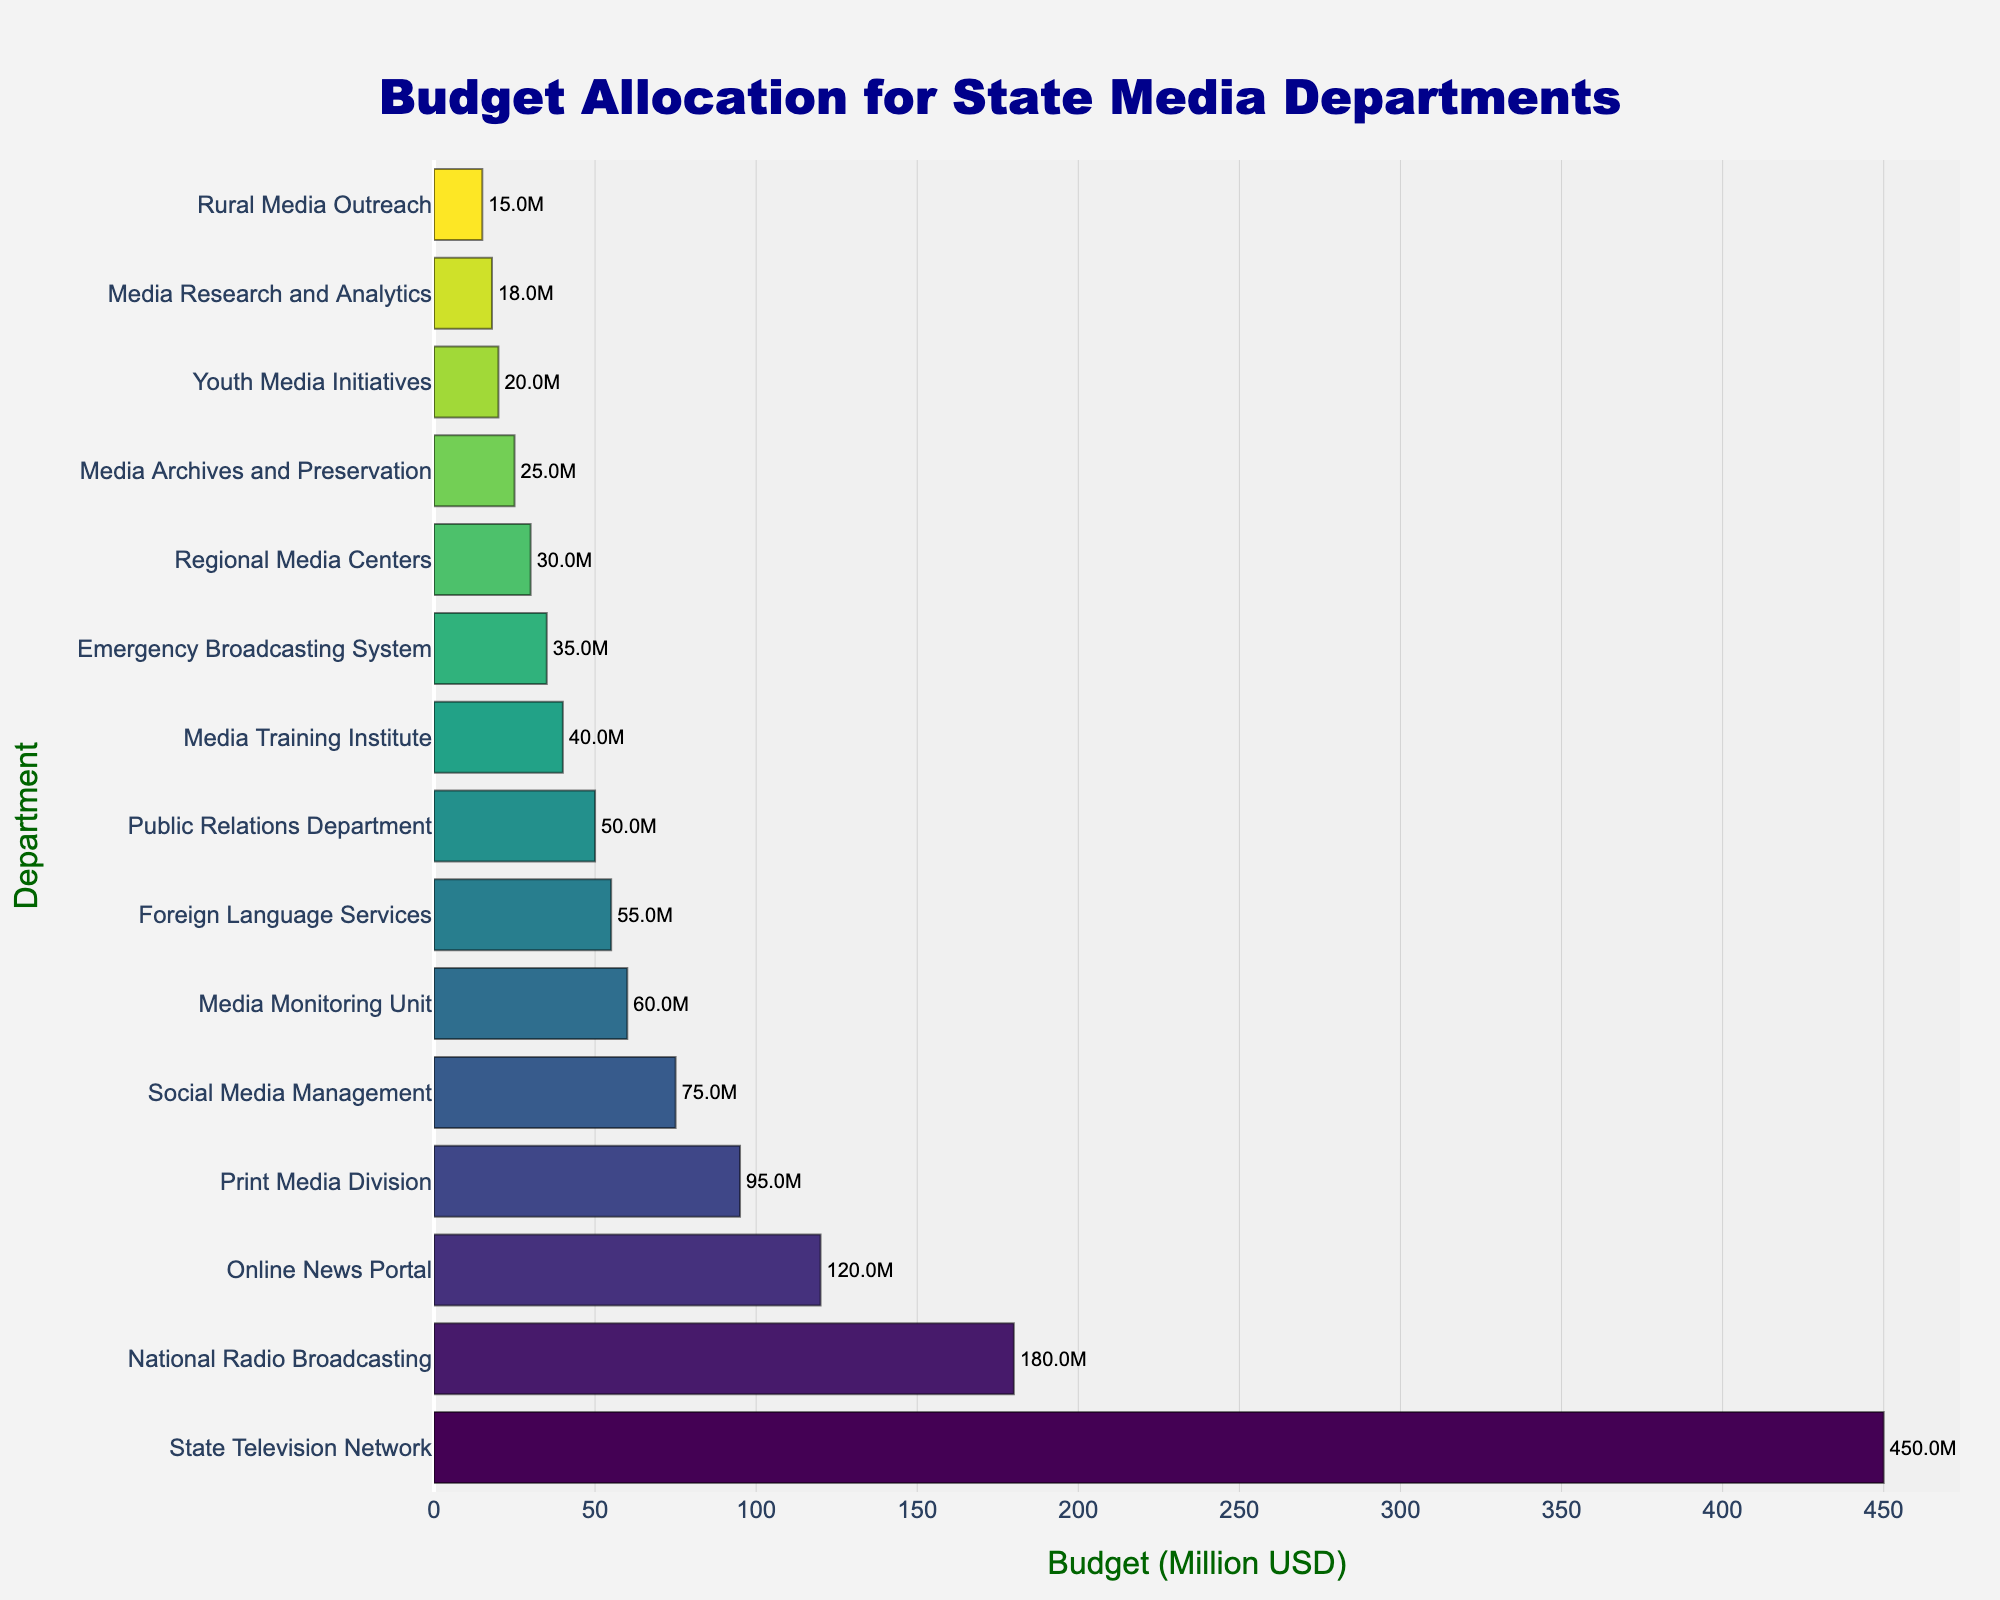Which department has the highest budget allocation? The figure shows a horizontal bar chart with the length of each bar representing the budget. The longest bar corresponds to the department with the highest budget allocation, which is "State Television Network".
Answer: State Television Network How much more budget does the State Television Network have compared to the National Radio Broadcasting? The bar representing the State Television Network is labeled with 450 million USD, while the National Radio Broadcasting bar is labeled with 180 million USD. The difference is 450 - 180 = 270 million USD.
Answer: 270 million USD Which departments have a budget below 50 million USD? The bars that are shorter than the 50 million USD mark indicate the departments with budgets below this threshold. These departments are Public Relations Department, Media Training Institute, Emergency Broadcasting System, Regional Media Centers, Media Archives and Preservation, Youth Media Initiatives, Media Research and Analytics, and Rural Media Outreach.
Answer: Public Relations Department, Media Training Institute, Emergency Broadcasting System, Regional Media Centers, Media Archives and Preservation, Youth Media Initiatives, Media Research and Analytics, Rural Media Outreach What is the combined budget of the Online News Portal and Print Media Division? The figure shows that the Online News Portal has a budget of 120 million USD and the Print Media Division has a budget of 95 million USD. Their combined budget is 120 + 95 = 215 million USD.
Answer: 215 million USD How does the budget of Social Media Management compare to that of Media Research and Analytics? Social Media Management has a budget of 75 million USD, and Media Research and Analytics has a budget of 18 million USD. The difference is 75 - 18 = 57 million USD, with Social Media Management having the greater budget.
Answer: Social Media Management has 57 million USD more Which departments are allocated the lowest and the highest budgets? The shortest and longest bars on the chart indicate the departments with the lowest and the highest budget allocations, respectively. The department with the lowest budget is "Rural Media Outreach" with 15 million USD, and the department with the highest budget is "State Television Network" with 450 million USD.
Answer: Rural Media Outreach, State Television Network What's the total budget allocation for the Media Monitoring Unit and Foreign Language Services? Media Monitoring Unit has a budget of 60 million USD, and Foreign Language Services has a budget of 55 million USD. Adding these together: 60 + 55 = 115 million USD.
Answer: 115 million USD How many departments have budgets greater than 100 million USD? The bars with budgets greater than 100 million USD are easy to distinguish by their length. The departments above this threshold are State Television Network, National Radio Broadcasting, and Online News Portal, making a total of 3 departments.
Answer: 3 What is the difference between the budget of the Emergency Broadcasting System and the Youth Media Initiatives? According to the chart, the Emergency Broadcasting System has a budget of 35 million USD and the Youth Media Initiatives have a budget of 20 million USD. The difference is 35 - 20 = 15 million USD.
Answer: 15 million USD 